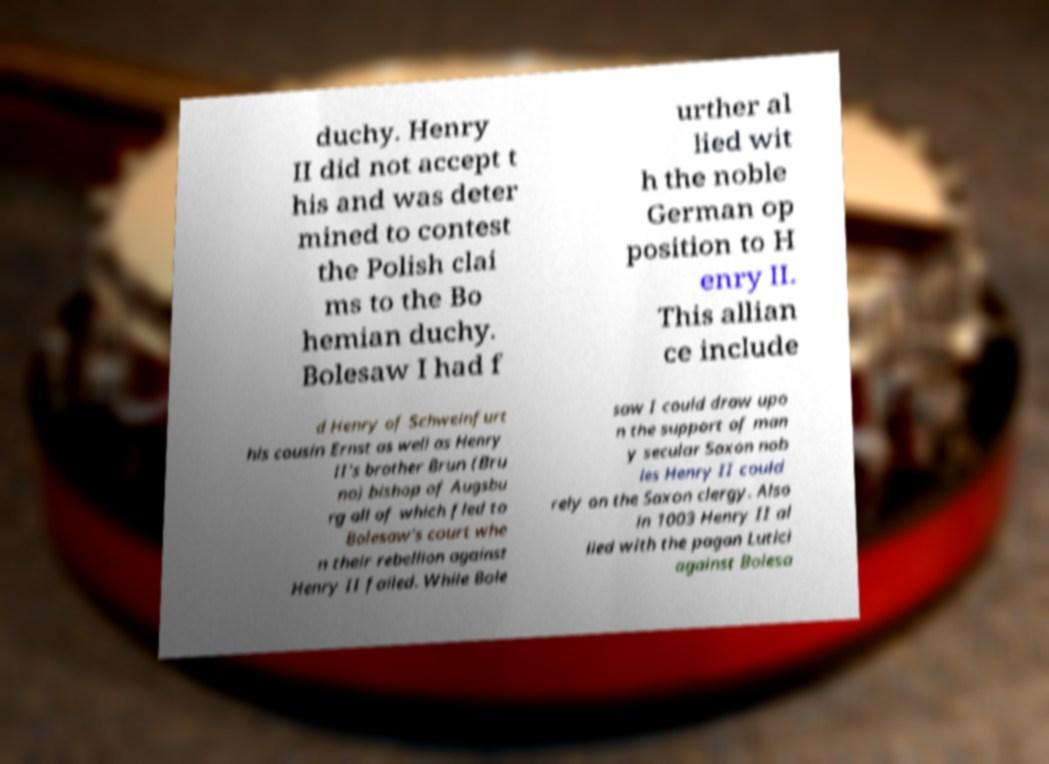For documentation purposes, I need the text within this image transcribed. Could you provide that? duchy. Henry II did not accept t his and was deter mined to contest the Polish clai ms to the Bo hemian duchy. Bolesaw I had f urther al lied wit h the noble German op position to H enry II. This allian ce include d Henry of Schweinfurt his cousin Ernst as well as Henry II's brother Brun (Bru no) bishop of Augsbu rg all of which fled to Bolesaw's court whe n their rebellion against Henry II failed. While Bole saw I could draw upo n the support of man y secular Saxon nob les Henry II could rely on the Saxon clergy. Also in 1003 Henry II al lied with the pagan Lutici against Bolesa 